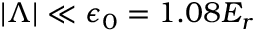Convert formula to latex. <formula><loc_0><loc_0><loc_500><loc_500>\begin{array} { r } { | \Lambda | \ll \epsilon _ { 0 } = 1 . 0 8 E _ { r } } \end{array}</formula> 